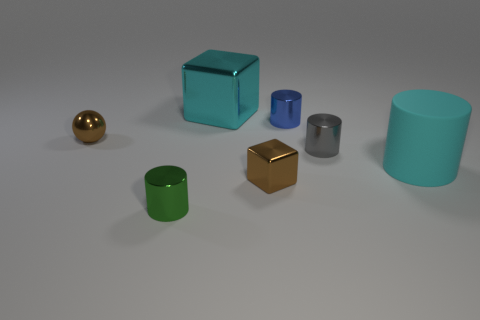Do the brown thing that is to the left of the large block and the large cyan thing that is behind the blue thing have the same shape? From the perspective of the image provided, the brown object to the left of the large teal block appears to be a cube, while the large cyan object behind the blue cylinder is also a cube. Thus, both objects indeed share the same cube shape. 